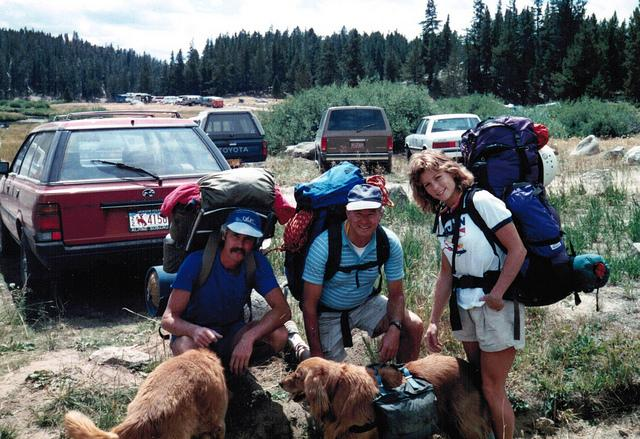What sort of adventure are they probably heading out on? hiking 